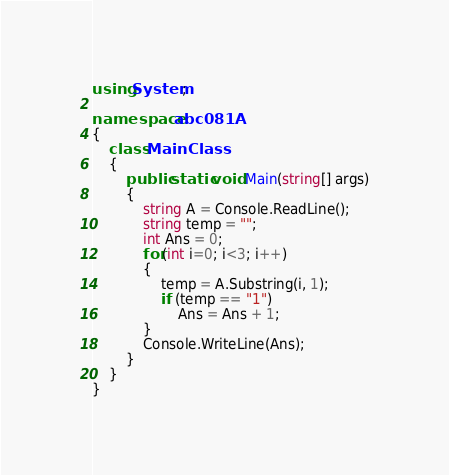Convert code to text. <code><loc_0><loc_0><loc_500><loc_500><_C#_>using System;

namespace abc081A
{
    class MainClass
    {
        public static void Main(string[] args)
        {
            string A = Console.ReadLine();
            string temp = "";
            int Ans = 0;
            for(int i=0; i<3; i++)
            {
                temp = A.Substring(i, 1);
                if (temp == "1")
                    Ans = Ans + 1;
            }
            Console.WriteLine(Ans);
        }
    }
}
</code> 